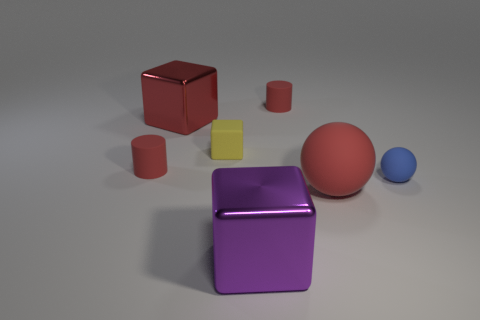Subtract all purple blocks. How many blocks are left? 2 Add 2 blocks. How many objects exist? 9 Subtract all cylinders. How many objects are left? 5 Subtract all big gray rubber cubes. Subtract all tiny blue objects. How many objects are left? 6 Add 7 large purple objects. How many large purple objects are left? 8 Add 5 small red rubber cylinders. How many small red rubber cylinders exist? 7 Subtract 0 brown cylinders. How many objects are left? 7 Subtract all gray balls. Subtract all purple cylinders. How many balls are left? 2 